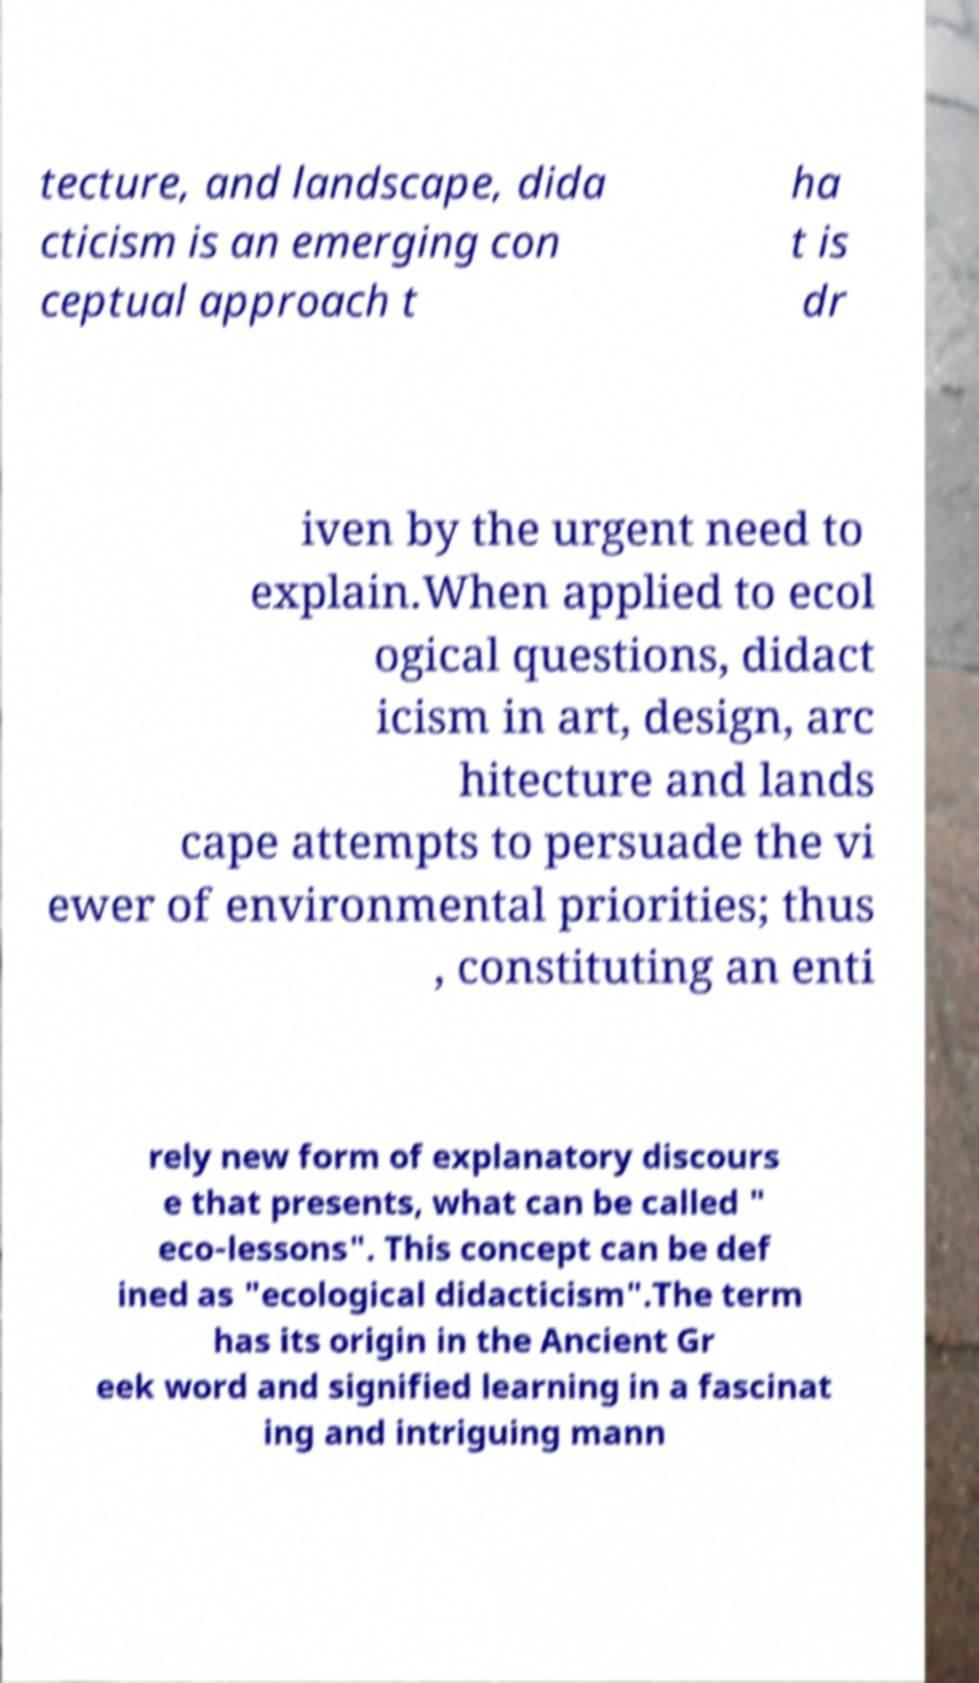Please read and relay the text visible in this image. What does it say? tecture, and landscape, dida cticism is an emerging con ceptual approach t ha t is dr iven by the urgent need to explain.When applied to ecol ogical questions, didact icism in art, design, arc hitecture and lands cape attempts to persuade the vi ewer of environmental priorities; thus , constituting an enti rely new form of explanatory discours e that presents, what can be called " eco-lessons". This concept can be def ined as "ecological didacticism".The term has its origin in the Ancient Gr eek word and signified learning in a fascinat ing and intriguing mann 